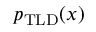<formula> <loc_0><loc_0><loc_500><loc_500>p _ { T L D } ( x )</formula> 